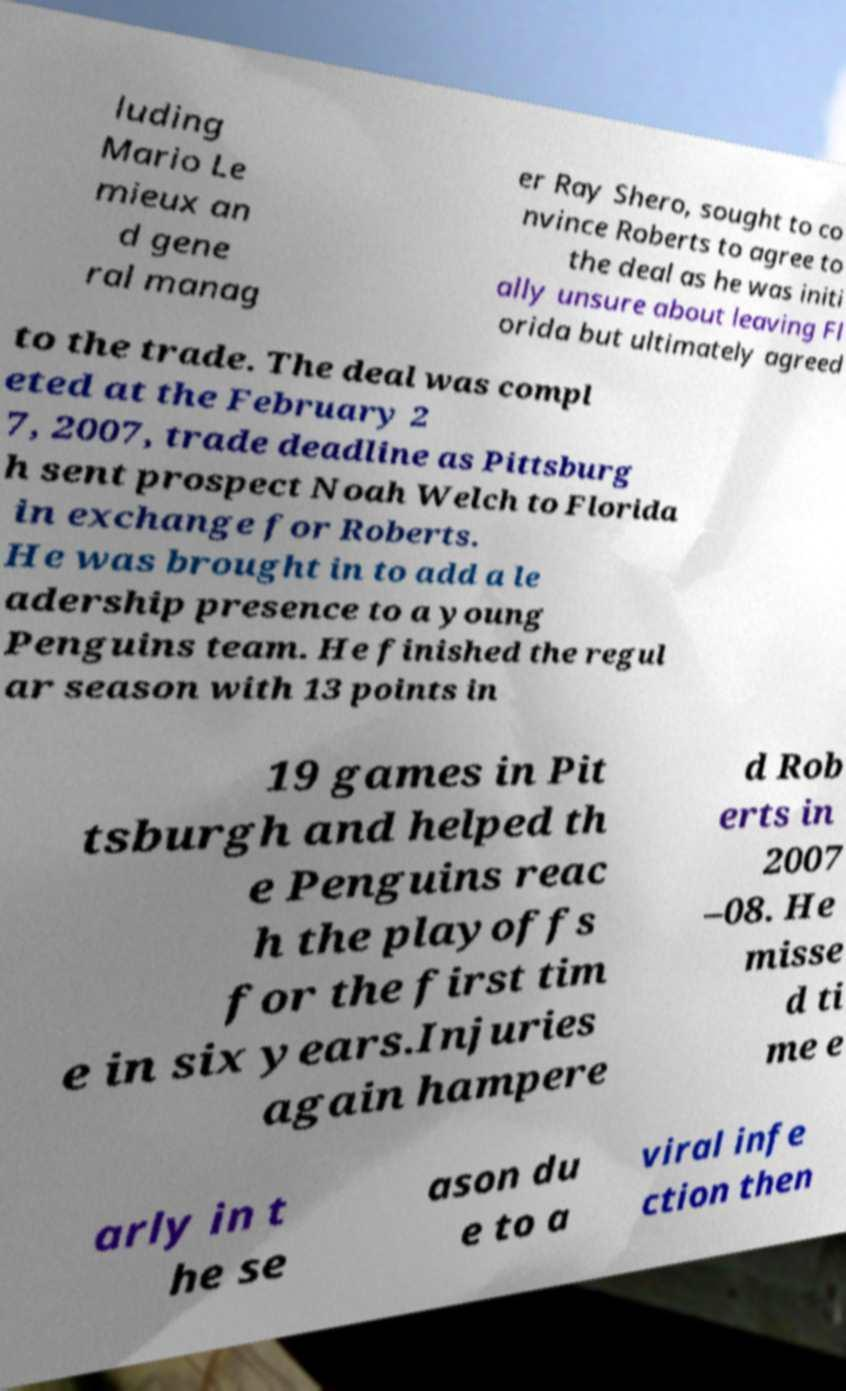Can you read and provide the text displayed in the image?This photo seems to have some interesting text. Can you extract and type it out for me? luding Mario Le mieux an d gene ral manag er Ray Shero, sought to co nvince Roberts to agree to the deal as he was initi ally unsure about leaving Fl orida but ultimately agreed to the trade. The deal was compl eted at the February 2 7, 2007, trade deadline as Pittsburg h sent prospect Noah Welch to Florida in exchange for Roberts. He was brought in to add a le adership presence to a young Penguins team. He finished the regul ar season with 13 points in 19 games in Pit tsburgh and helped th e Penguins reac h the playoffs for the first tim e in six years.Injuries again hampere d Rob erts in 2007 –08. He misse d ti me e arly in t he se ason du e to a viral infe ction then 